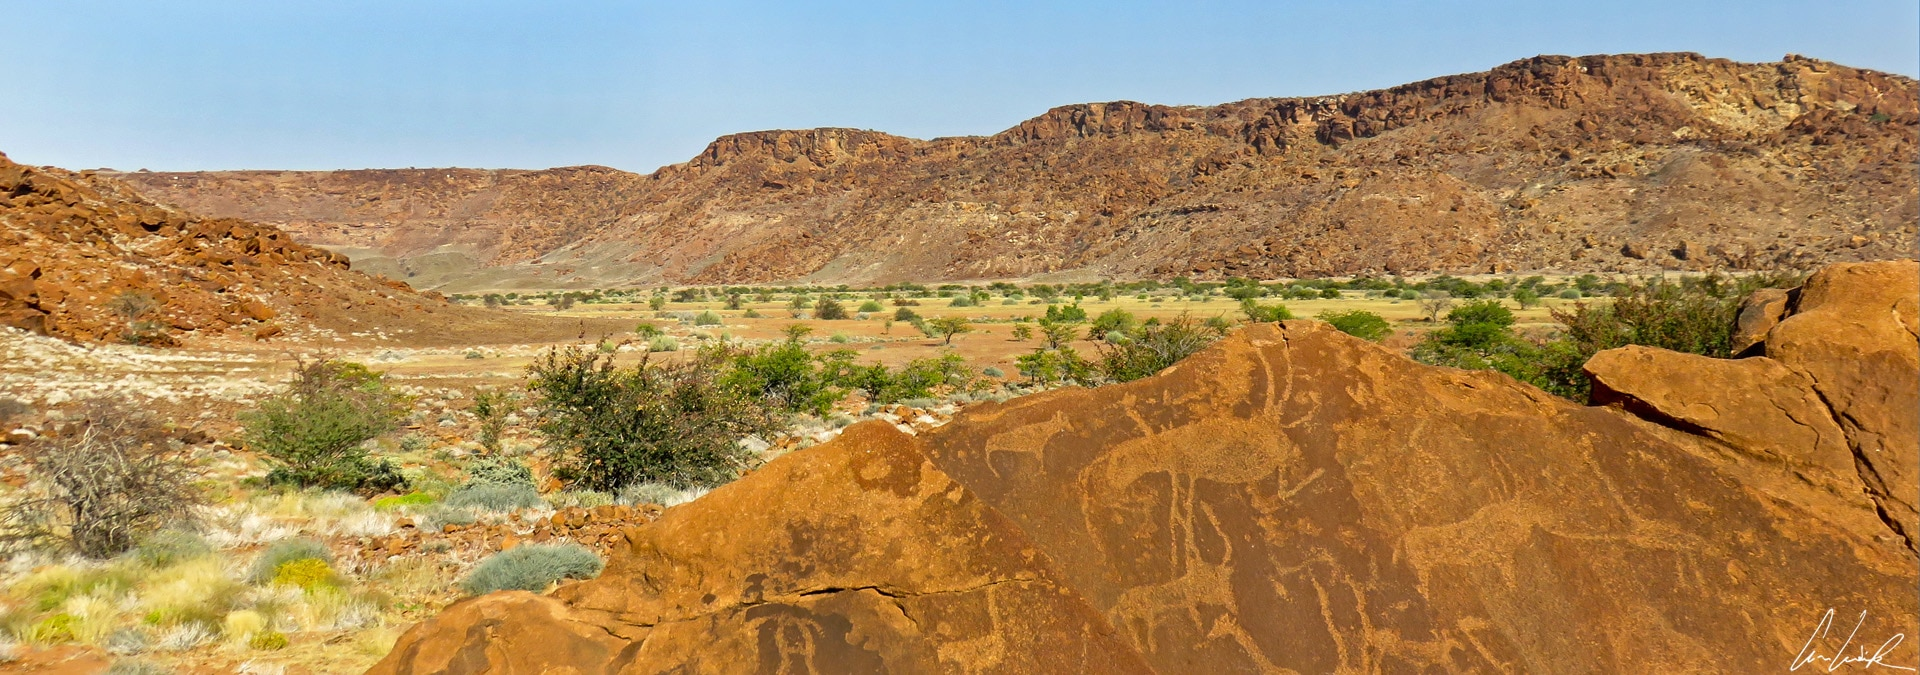Describe a fictional expedition discovering this site for the first time. The year was 1902, and Dr. Evelyn Carter, a seasoned archaeologist with a thirst for discovery, led her small team through the unforgiving Namibian desert. Weeks of hardship had taken their toll, but just as supplies dwindled and spirits wavered, a member of the crew stumbled upon an astonishing sight - an expanse of reddish rocks adorned with intricate engravings. Dr. Carter examined the petroglyphs closely, her heart racing as she realized they had discovered an ancient gallery of human expression. The team meticulously documented their findings, understanding the immense historical value of these artworks. News of Twyfelfontein’s discovery spread worldwide, leading to deeper investigations and immeasurable contributions to our understanding of ancient cultures. Dr. Carter’s expedition remains celebrated as a testament to human perseverance and the joy of unearthing our shared heritage. 